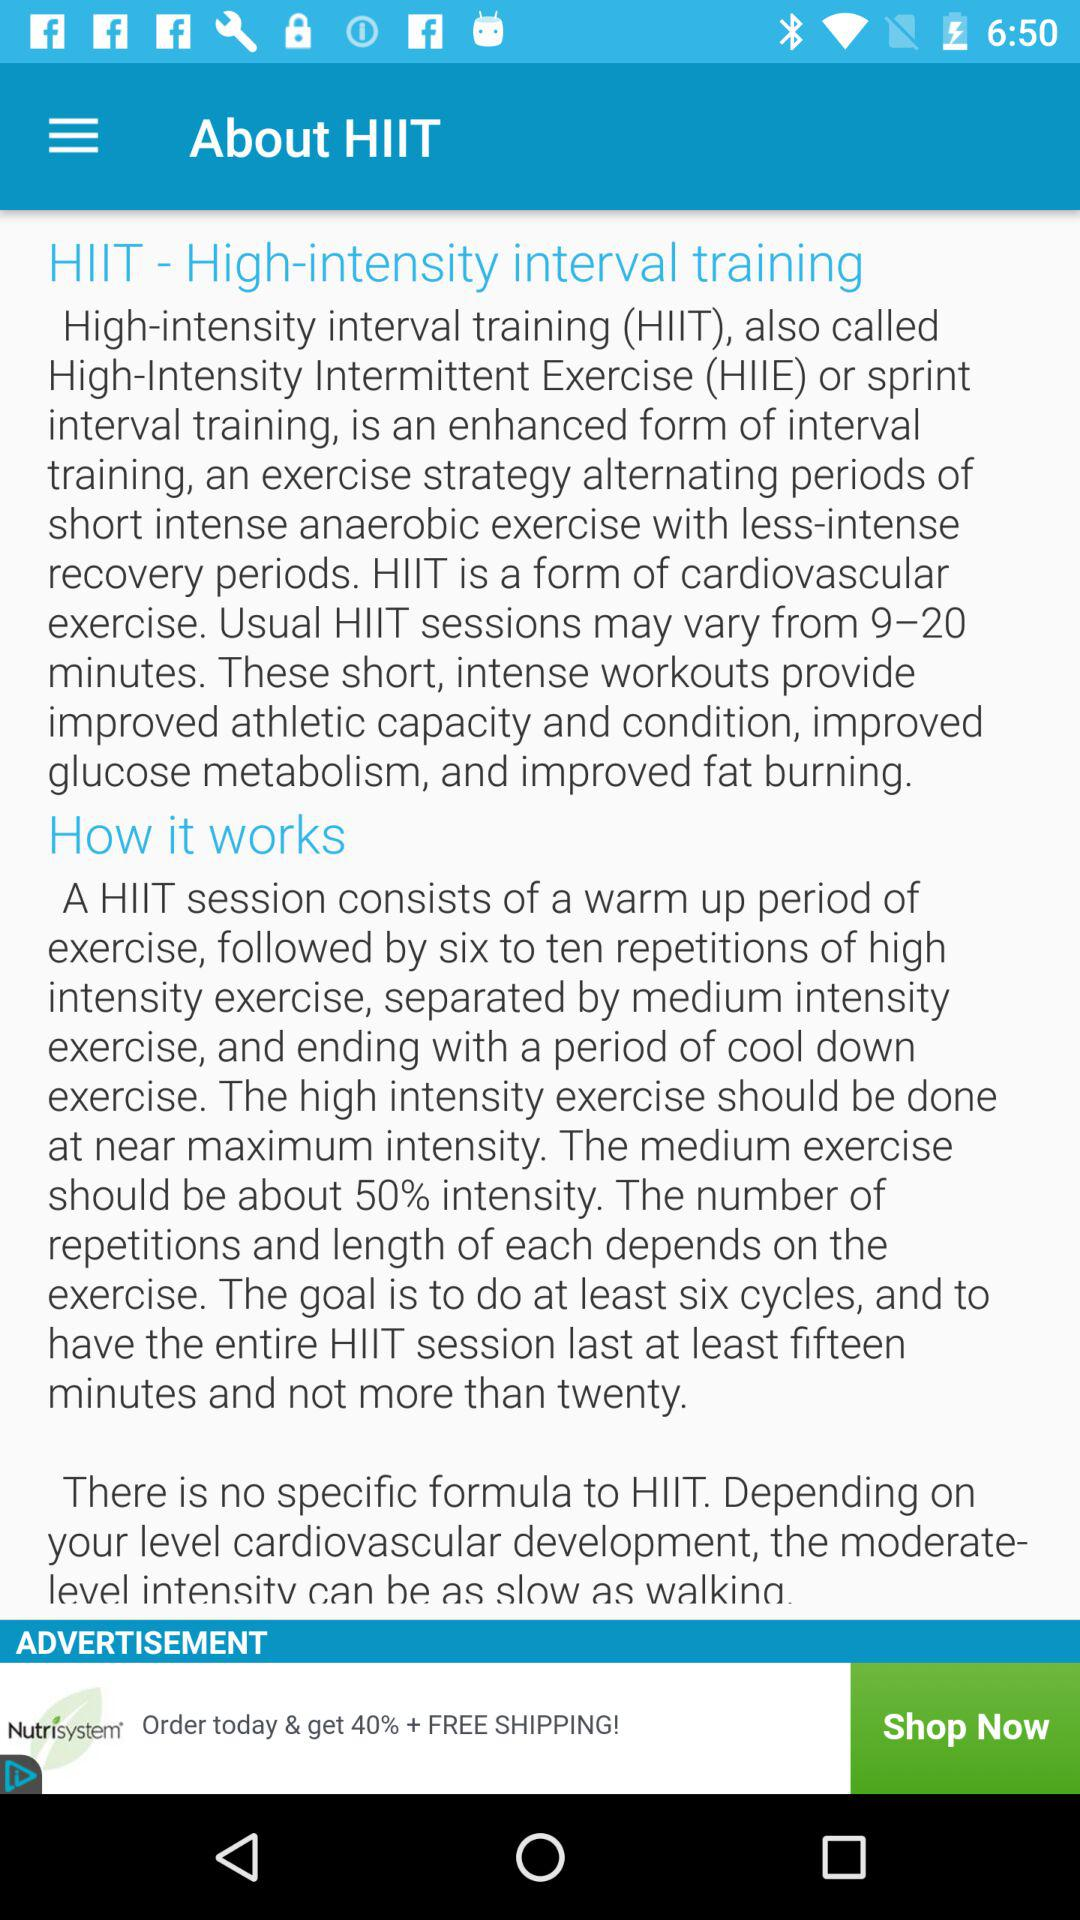How many cycles are to be completed to achieve the goal? To achieve the goal, at least 6 cycles are to be completed. 